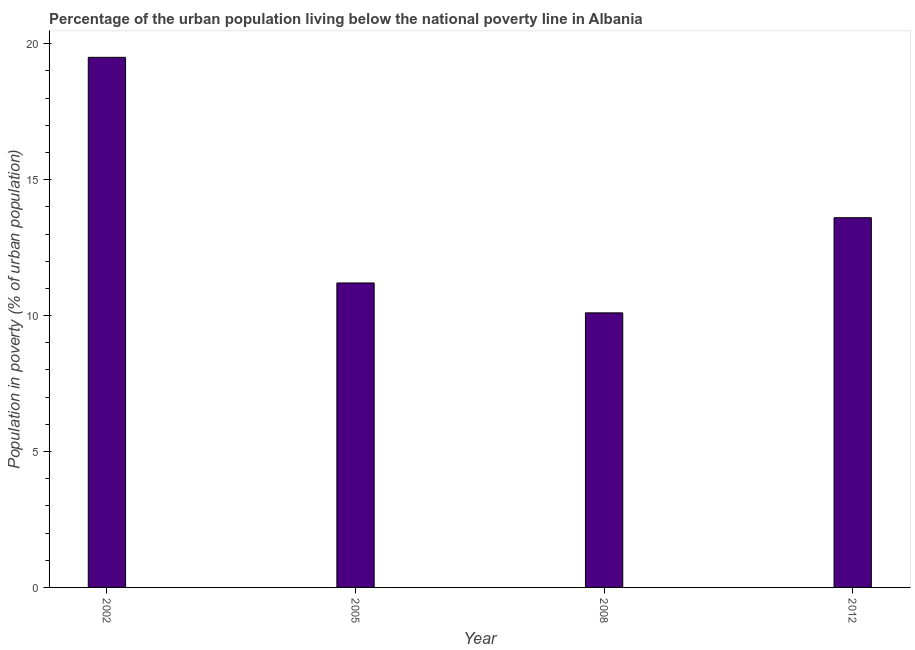Does the graph contain grids?
Your response must be concise. No. What is the title of the graph?
Make the answer very short. Percentage of the urban population living below the national poverty line in Albania. What is the label or title of the Y-axis?
Provide a short and direct response. Population in poverty (% of urban population). Across all years, what is the minimum percentage of urban population living below poverty line?
Ensure brevity in your answer.  10.1. What is the sum of the percentage of urban population living below poverty line?
Your response must be concise. 54.4. What is the difference between the percentage of urban population living below poverty line in 2002 and 2008?
Your response must be concise. 9.4. What is the average percentage of urban population living below poverty line per year?
Make the answer very short. 13.6. What is the median percentage of urban population living below poverty line?
Give a very brief answer. 12.4. In how many years, is the percentage of urban population living below poverty line greater than 7 %?
Give a very brief answer. 4. What is the ratio of the percentage of urban population living below poverty line in 2002 to that in 2005?
Your answer should be very brief. 1.74. Is the percentage of urban population living below poverty line in 2005 less than that in 2008?
Provide a succinct answer. No. Is the difference between the percentage of urban population living below poverty line in 2002 and 2012 greater than the difference between any two years?
Your answer should be compact. No. What is the difference between the highest and the second highest percentage of urban population living below poverty line?
Keep it short and to the point. 5.9. Is the sum of the percentage of urban population living below poverty line in 2005 and 2008 greater than the maximum percentage of urban population living below poverty line across all years?
Your answer should be very brief. Yes. How many years are there in the graph?
Your response must be concise. 4. Are the values on the major ticks of Y-axis written in scientific E-notation?
Provide a short and direct response. No. What is the Population in poverty (% of urban population) in 2002?
Ensure brevity in your answer.  19.5. What is the Population in poverty (% of urban population) of 2005?
Your response must be concise. 11.2. What is the Population in poverty (% of urban population) of 2008?
Your response must be concise. 10.1. What is the Population in poverty (% of urban population) of 2012?
Your answer should be compact. 13.6. What is the difference between the Population in poverty (% of urban population) in 2002 and 2005?
Your answer should be very brief. 8.3. What is the difference between the Population in poverty (% of urban population) in 2005 and 2008?
Provide a short and direct response. 1.1. What is the ratio of the Population in poverty (% of urban population) in 2002 to that in 2005?
Provide a short and direct response. 1.74. What is the ratio of the Population in poverty (% of urban population) in 2002 to that in 2008?
Your answer should be very brief. 1.93. What is the ratio of the Population in poverty (% of urban population) in 2002 to that in 2012?
Provide a succinct answer. 1.43. What is the ratio of the Population in poverty (% of urban population) in 2005 to that in 2008?
Give a very brief answer. 1.11. What is the ratio of the Population in poverty (% of urban population) in 2005 to that in 2012?
Provide a short and direct response. 0.82. What is the ratio of the Population in poverty (% of urban population) in 2008 to that in 2012?
Keep it short and to the point. 0.74. 